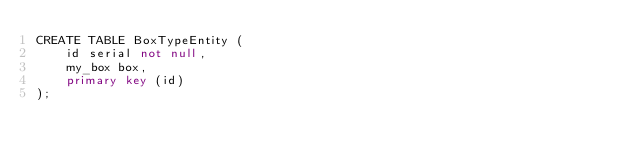<code> <loc_0><loc_0><loc_500><loc_500><_SQL_>CREATE TABLE BoxTypeEntity (
    id serial not null,
    my_box box,
    primary key (id)
);
</code> 